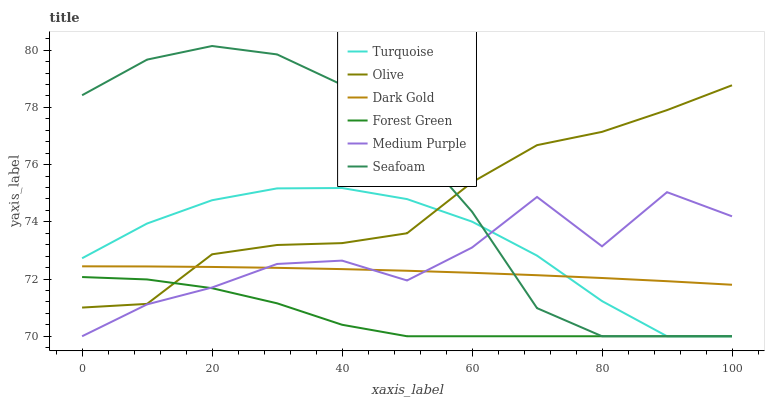Does Forest Green have the minimum area under the curve?
Answer yes or no. Yes. Does Seafoam have the maximum area under the curve?
Answer yes or no. Yes. Does Dark Gold have the minimum area under the curve?
Answer yes or no. No. Does Dark Gold have the maximum area under the curve?
Answer yes or no. No. Is Dark Gold the smoothest?
Answer yes or no. Yes. Is Medium Purple the roughest?
Answer yes or no. Yes. Is Seafoam the smoothest?
Answer yes or no. No. Is Seafoam the roughest?
Answer yes or no. No. Does Turquoise have the lowest value?
Answer yes or no. Yes. Does Dark Gold have the lowest value?
Answer yes or no. No. Does Seafoam have the highest value?
Answer yes or no. Yes. Does Dark Gold have the highest value?
Answer yes or no. No. Is Forest Green less than Dark Gold?
Answer yes or no. Yes. Is Olive greater than Medium Purple?
Answer yes or no. Yes. Does Forest Green intersect Olive?
Answer yes or no. Yes. Is Forest Green less than Olive?
Answer yes or no. No. Is Forest Green greater than Olive?
Answer yes or no. No. Does Forest Green intersect Dark Gold?
Answer yes or no. No. 